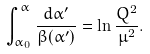Convert formula to latex. <formula><loc_0><loc_0><loc_500><loc_500>\int _ { \alpha _ { 0 } } ^ { \alpha } \frac { d \alpha ^ { \prime } } { \beta ( \alpha ^ { \prime } ) } = \ln \frac { Q ^ { 2 } } { \mu ^ { 2 } } .</formula> 